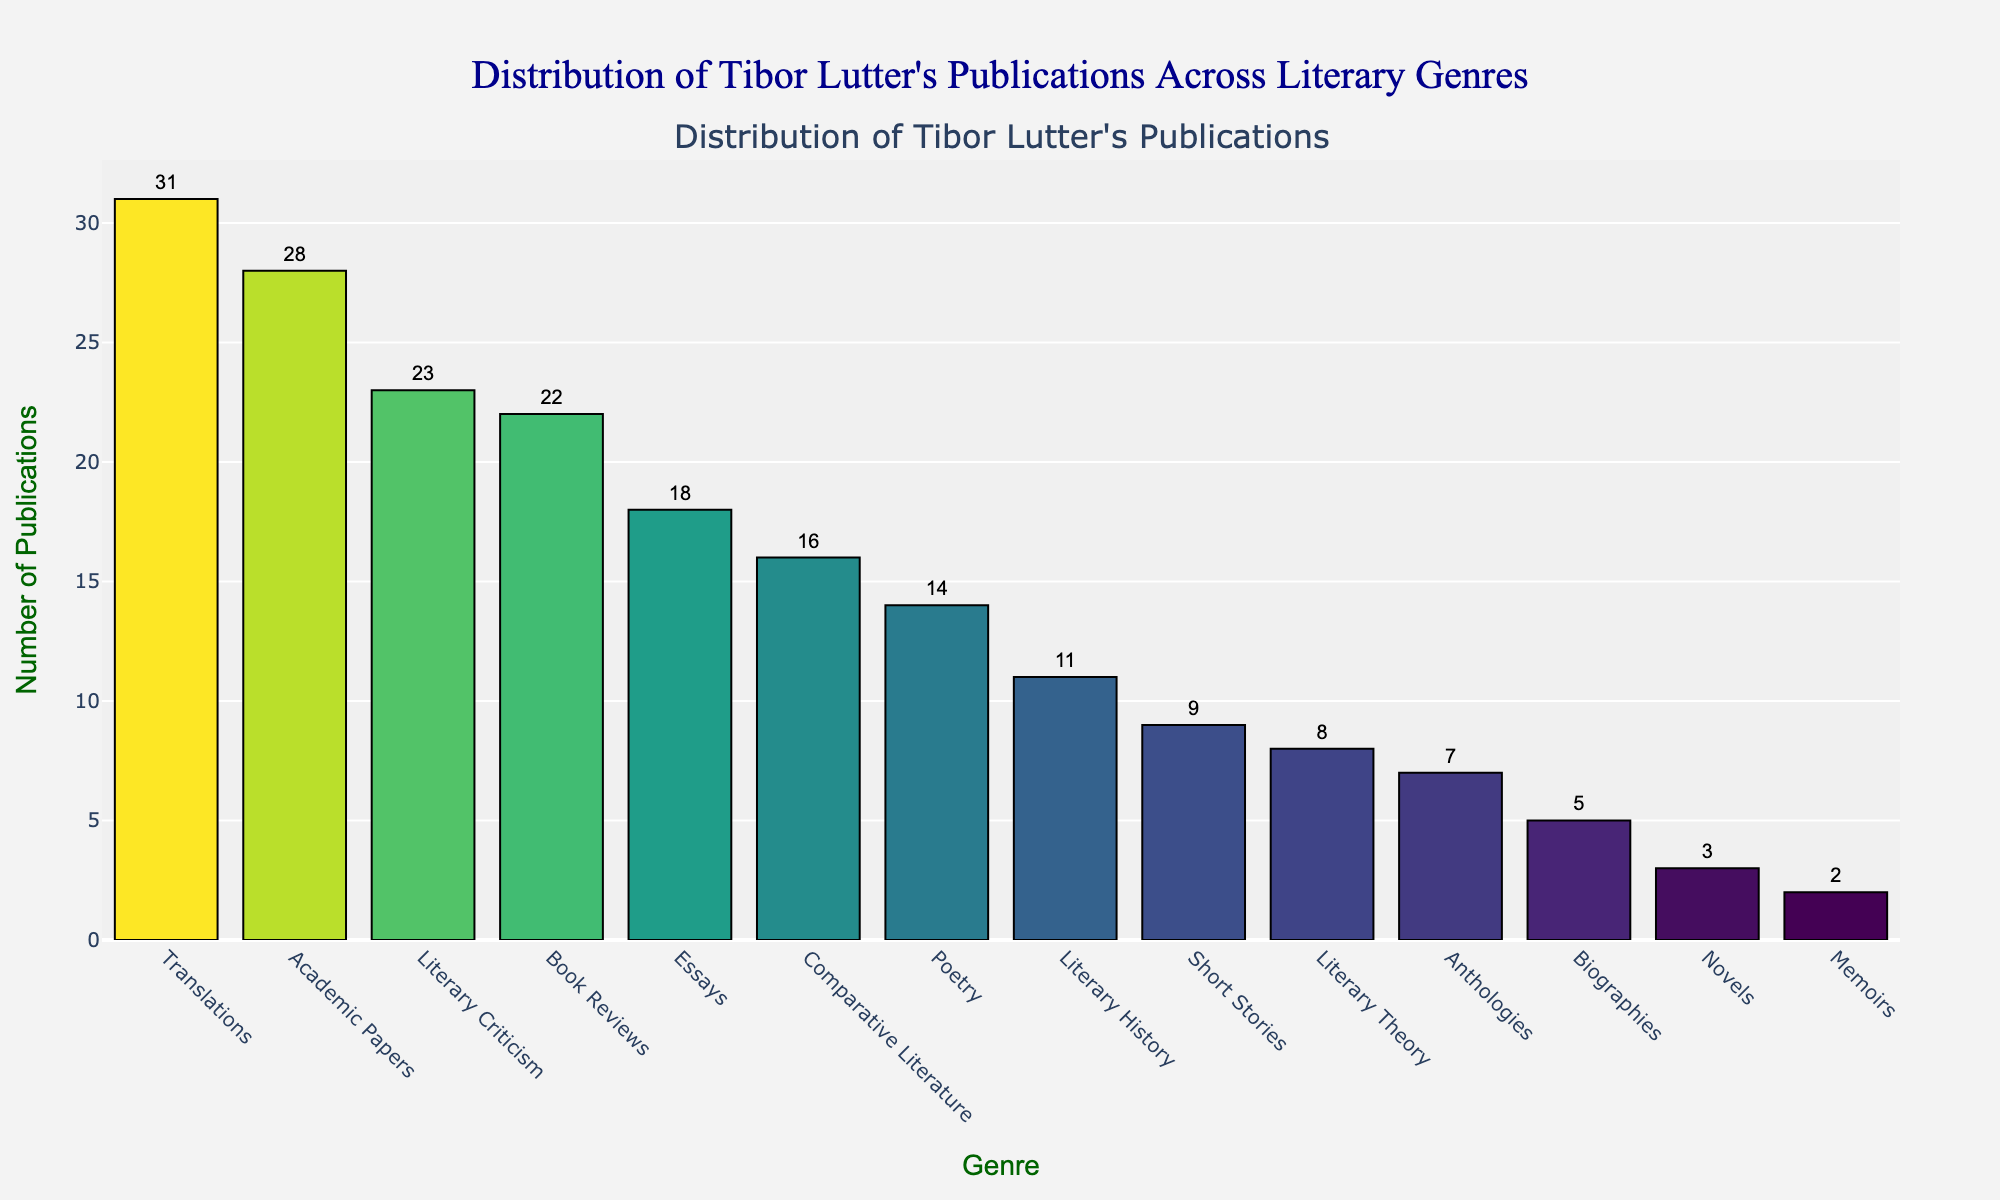What genre has the highest number of publications? The bar for Translations is the tallest, indicating it has the highest number of publications.
Answer: Translations How many publications are in Novels compared to Biographies? The bar for Novels is shorter and has a value of 3, while the bar for Biographies is slightly taller with a value of 5. 5 - 3 = 2 more publications for Biographies.
Answer: 2 more for Biographies What is the total number of Tibor Lutter's publications in Poetry, Essays, and Short Stories? Add the values for Poetry (14), Essays (18), and Short Stories (9): 14 + 18 + 9 = 41.
Answer: 41 How much higher is the number of publications in Academic Papers compared to Book Reviews? The value for Academic Papers is 28 and Book Reviews is 22. 28 - 22 = 6.
Answer: 6 more Which genre has the smallest number of publications? The bar for Memoirs is the shortest with a value of 2.
Answer: Memoirs What is the combined number of publications across Literary Criticism and Literary Theory? Add the values for Literary Criticism (23) and Literary Theory (8): 23 + 8 = 31.
Answer: 31 How many genres have fewer than 10 publications? The genres with fewer than 10 publications are Novels (3), Biographies (5), Short Stories (9), Literary Theory (8), Anthologies (7), and Memoirs (2). That's 6 genres.
Answer: 6 Is the number of Book Reviews greater than that of Poetry? The value for Book Reviews (22) is greater than that of Poetry (14).
Answer: Yes What is the difference in the number of publications between Essays and Comparative Literature? The value for Essays is 18 and Comparative Literature is 16. 18 - 16 = 2.
Answer: 2 more for Essays How many publications are there in Academic Papers and Anthologies combined? Add the values for Academic Papers (28) and Anthologies (7): 28 + 7 = 35.
Answer: 35 